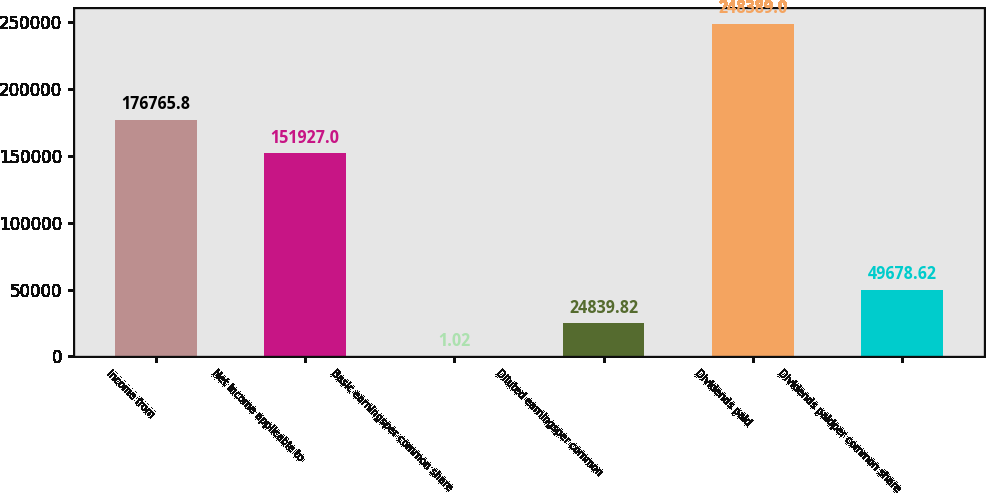Convert chart. <chart><loc_0><loc_0><loc_500><loc_500><bar_chart><fcel>Income from<fcel>Net income applicable to<fcel>Basic earningsper common share<fcel>Diluted earningsper common<fcel>Dividends paid<fcel>Dividends paidper common share<nl><fcel>176766<fcel>151927<fcel>1.02<fcel>24839.8<fcel>248389<fcel>49678.6<nl></chart> 